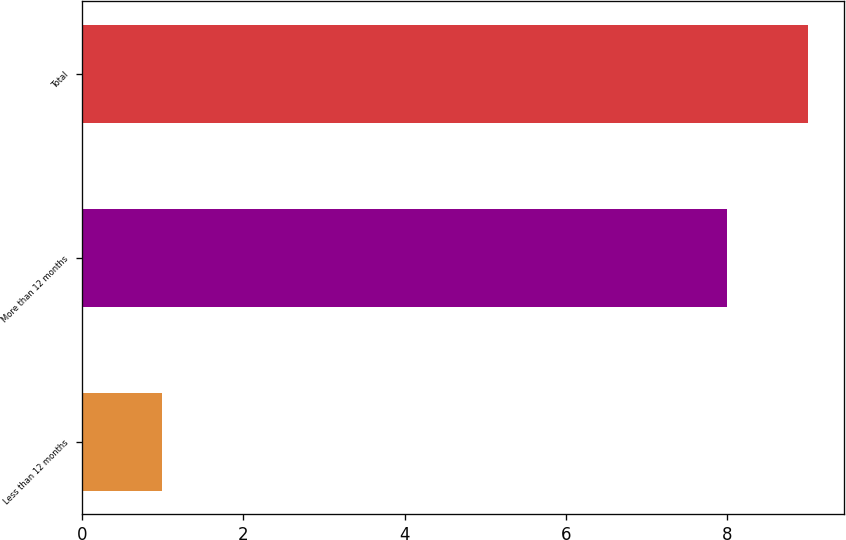Convert chart to OTSL. <chart><loc_0><loc_0><loc_500><loc_500><bar_chart><fcel>Less than 12 months<fcel>More than 12 months<fcel>Total<nl><fcel>1<fcel>8<fcel>9<nl></chart> 